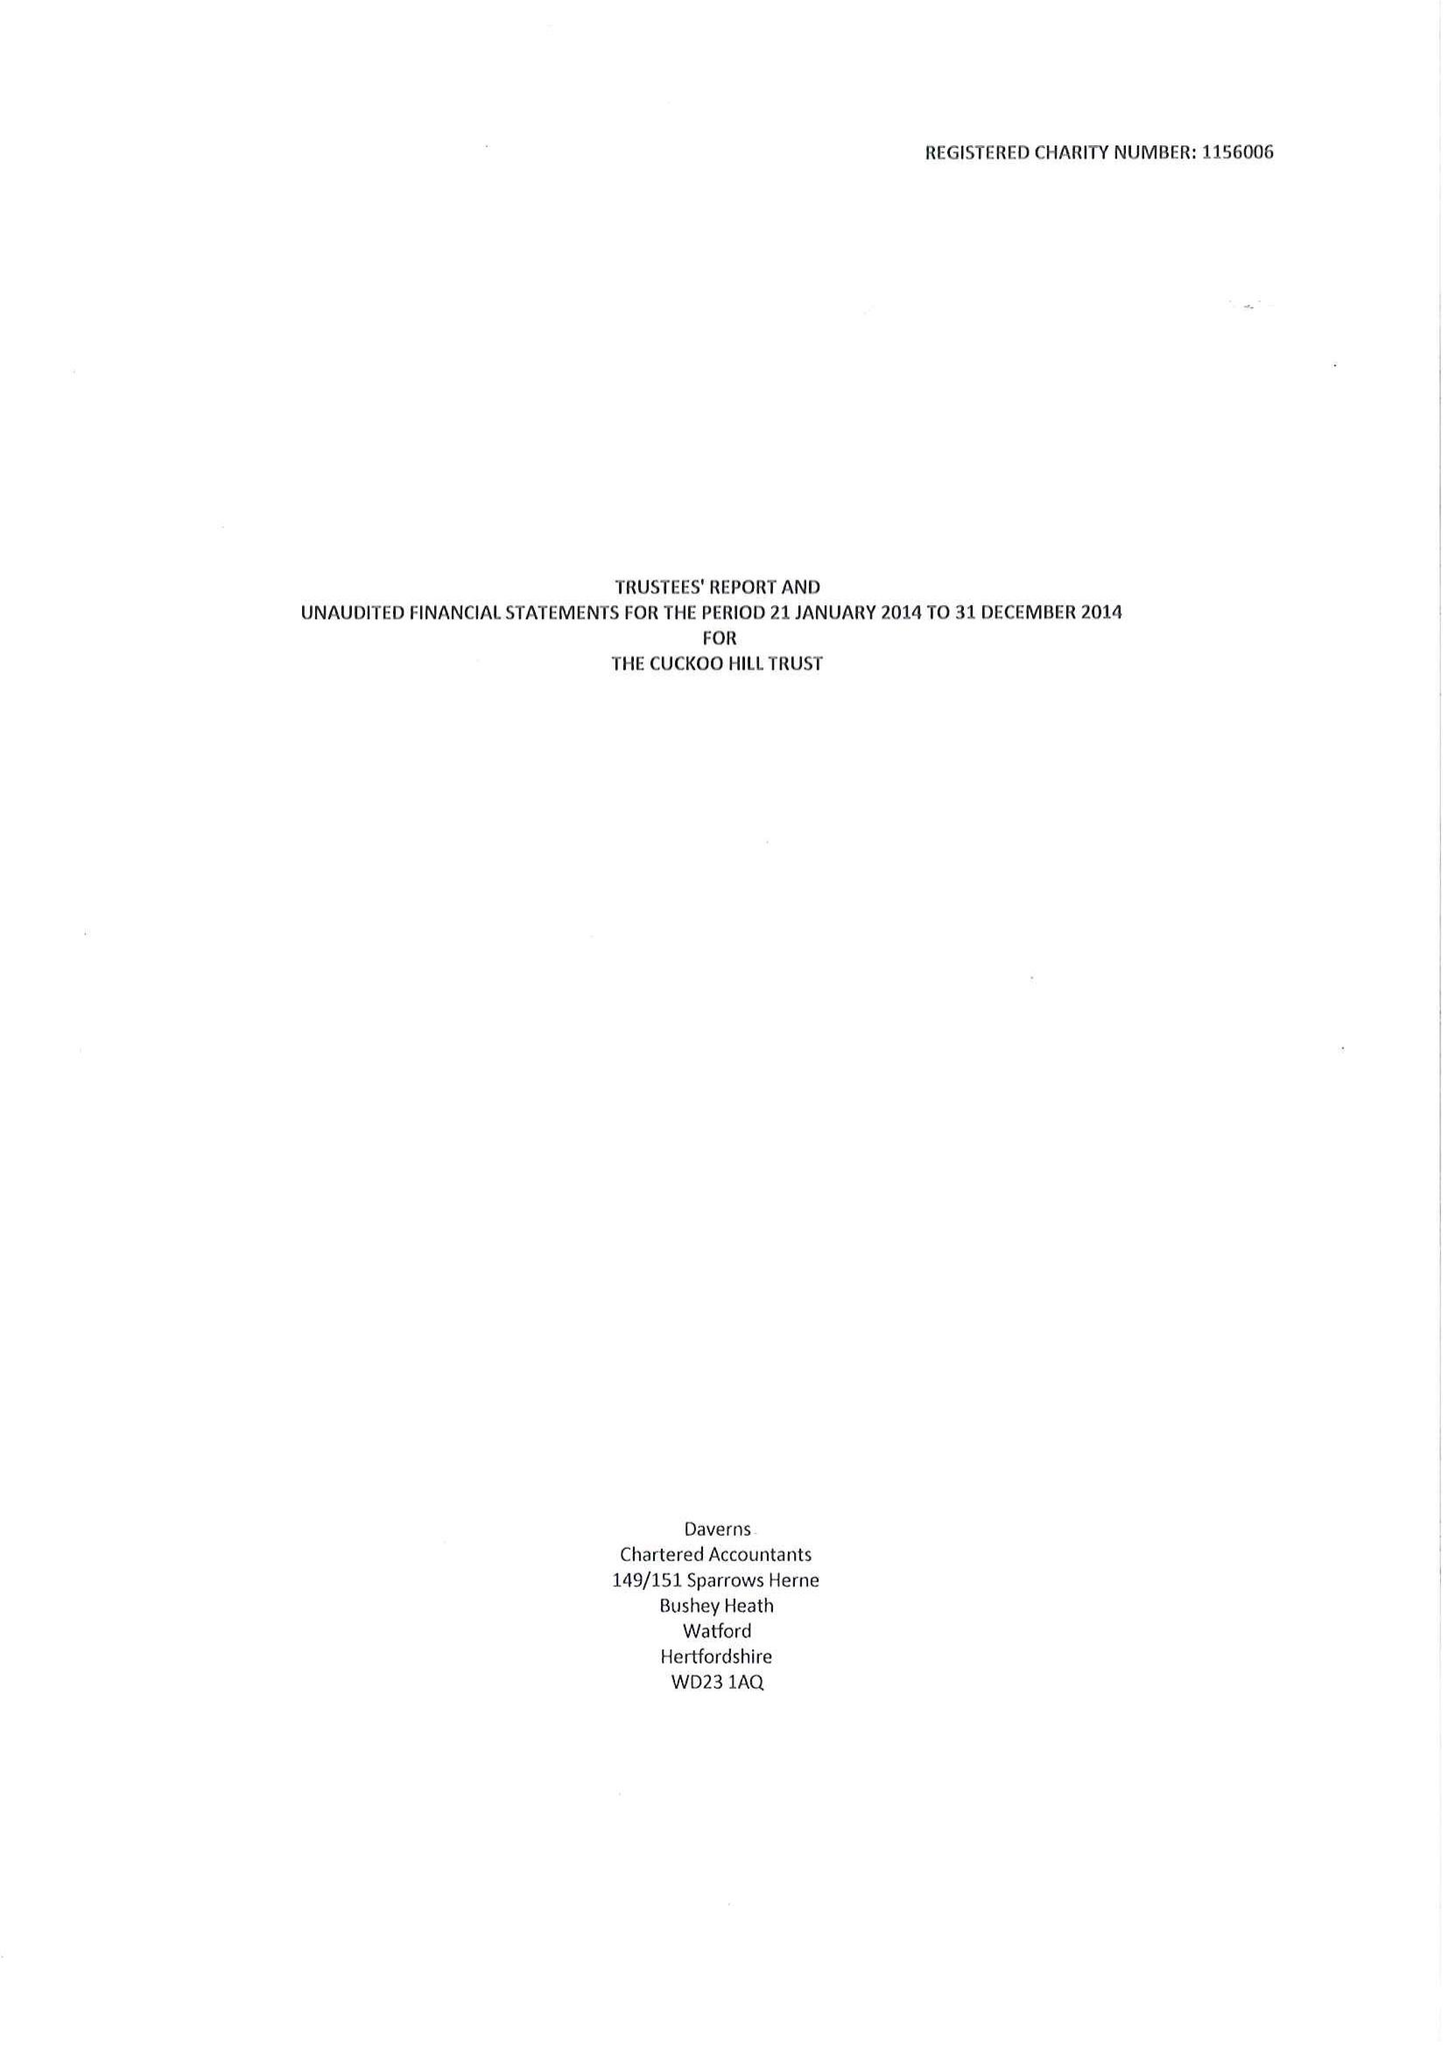What is the value for the spending_annually_in_british_pounds?
Answer the question using a single word or phrase. 14251.00 